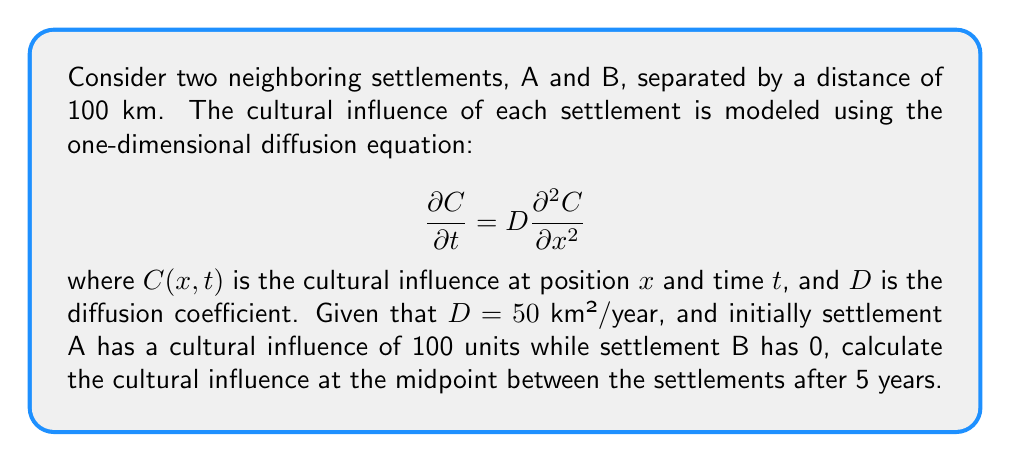Solve this math problem. To solve this problem, we'll use the solution to the one-dimensional diffusion equation for an initial point source:

$$C(x,t) = \frac{M}{\sqrt{4\pi Dt}} e^{-\frac{x^2}{4Dt}}$$

where $M$ is the initial amount of cultural influence.

1. We have two point sources: settlement A at $x = 0$ and settlement B at $x = 100$ km.

2. The midpoint is at $x = 50$ km.

3. For settlement A:
   $M_A = 100$, $x = 50$ km, $t = 5$ years, $D = 50$ km²/year
   
   $$C_A(50,5) = \frac{100}{\sqrt{4\pi \cdot 50 \cdot 5}} e^{-\frac{50^2}{4 \cdot 50 \cdot 5}} = 7.97$$

4. For settlement B:
   $M_B = 0$, so it doesn't contribute to the cultural influence.

5. The total cultural influence at the midpoint is the sum of the influences from both settlements:

   $$C_{total}(50,5) = C_A(50,5) + C_B(50,5) = 7.97 + 0 = 7.97$$
Answer: 7.97 units 